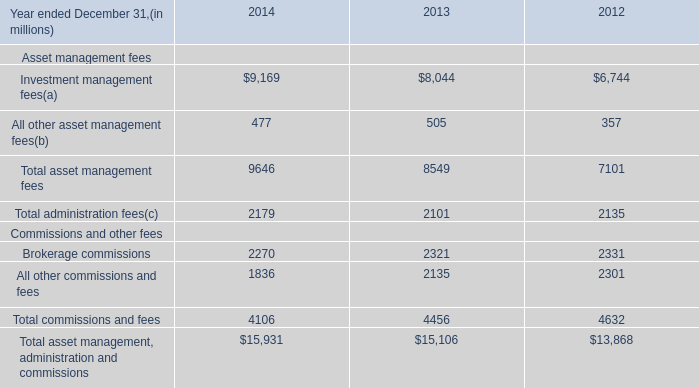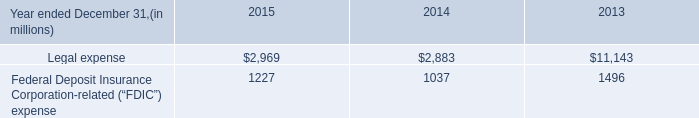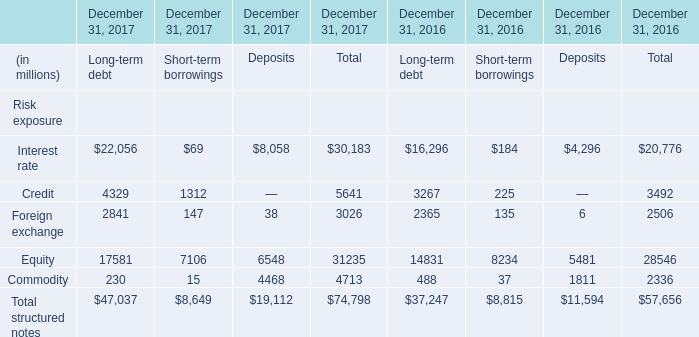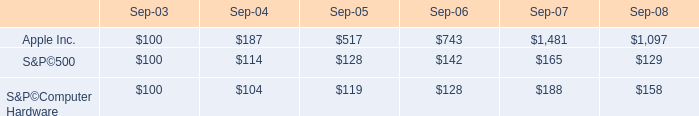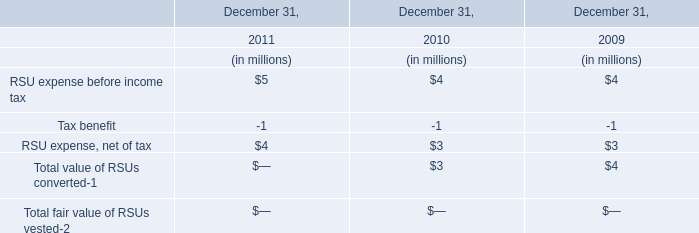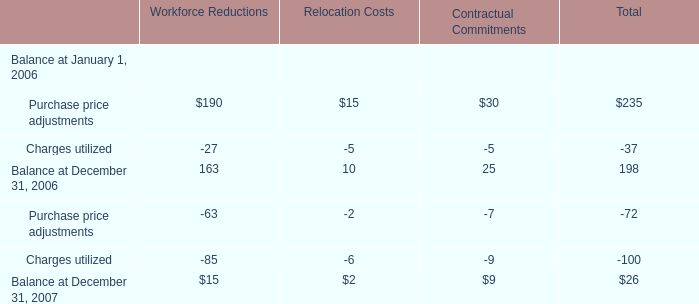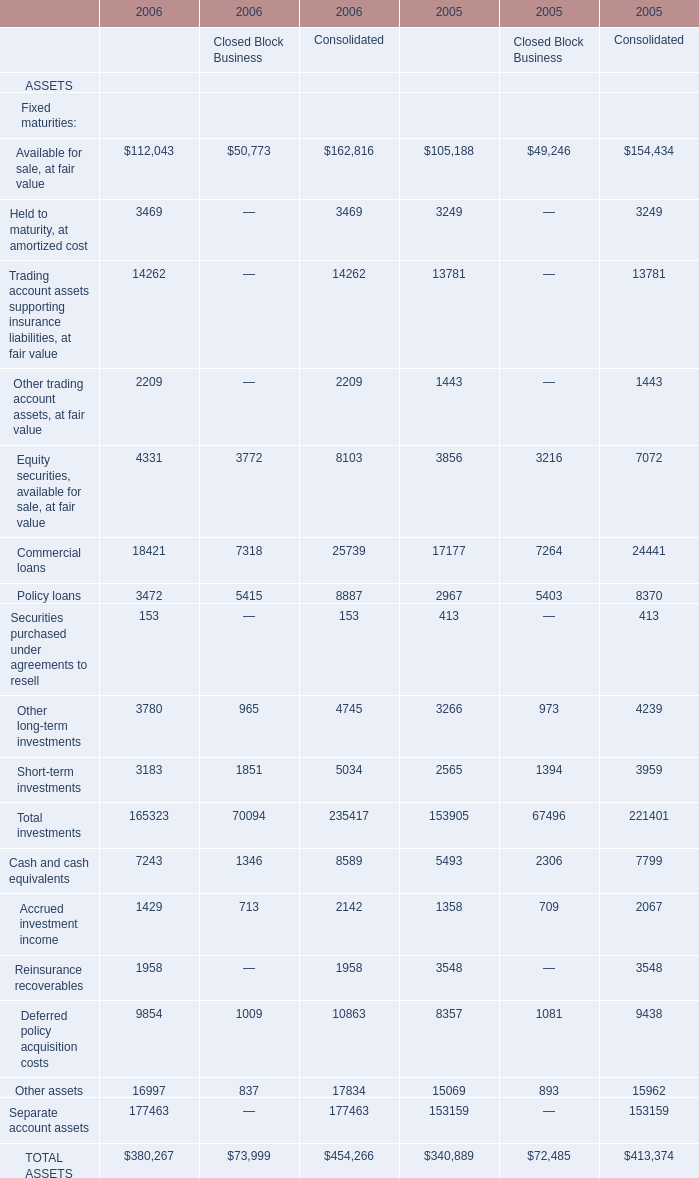What's the average of Future policy benefits LIABILITIES of 2006 Consolidated, and Interest rate of December 31, 2017 Deposits ? 
Computations: ((106951.0 + 8058.0) / 2)
Answer: 57504.5. 